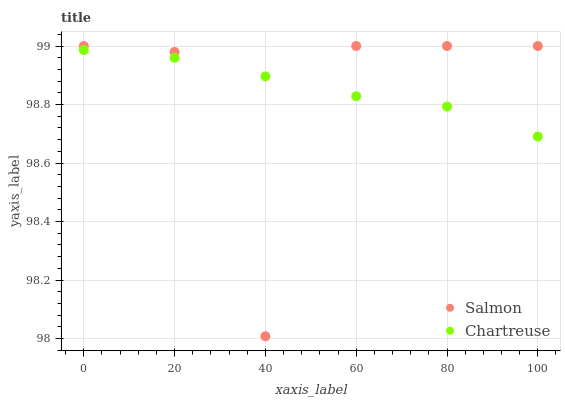Does Salmon have the minimum area under the curve?
Answer yes or no. Yes. Does Chartreuse have the maximum area under the curve?
Answer yes or no. Yes. Does Salmon have the maximum area under the curve?
Answer yes or no. No. Is Chartreuse the smoothest?
Answer yes or no. Yes. Is Salmon the roughest?
Answer yes or no. Yes. Is Salmon the smoothest?
Answer yes or no. No. Does Salmon have the lowest value?
Answer yes or no. Yes. Does Salmon have the highest value?
Answer yes or no. Yes. Does Salmon intersect Chartreuse?
Answer yes or no. Yes. Is Salmon less than Chartreuse?
Answer yes or no. No. Is Salmon greater than Chartreuse?
Answer yes or no. No. 